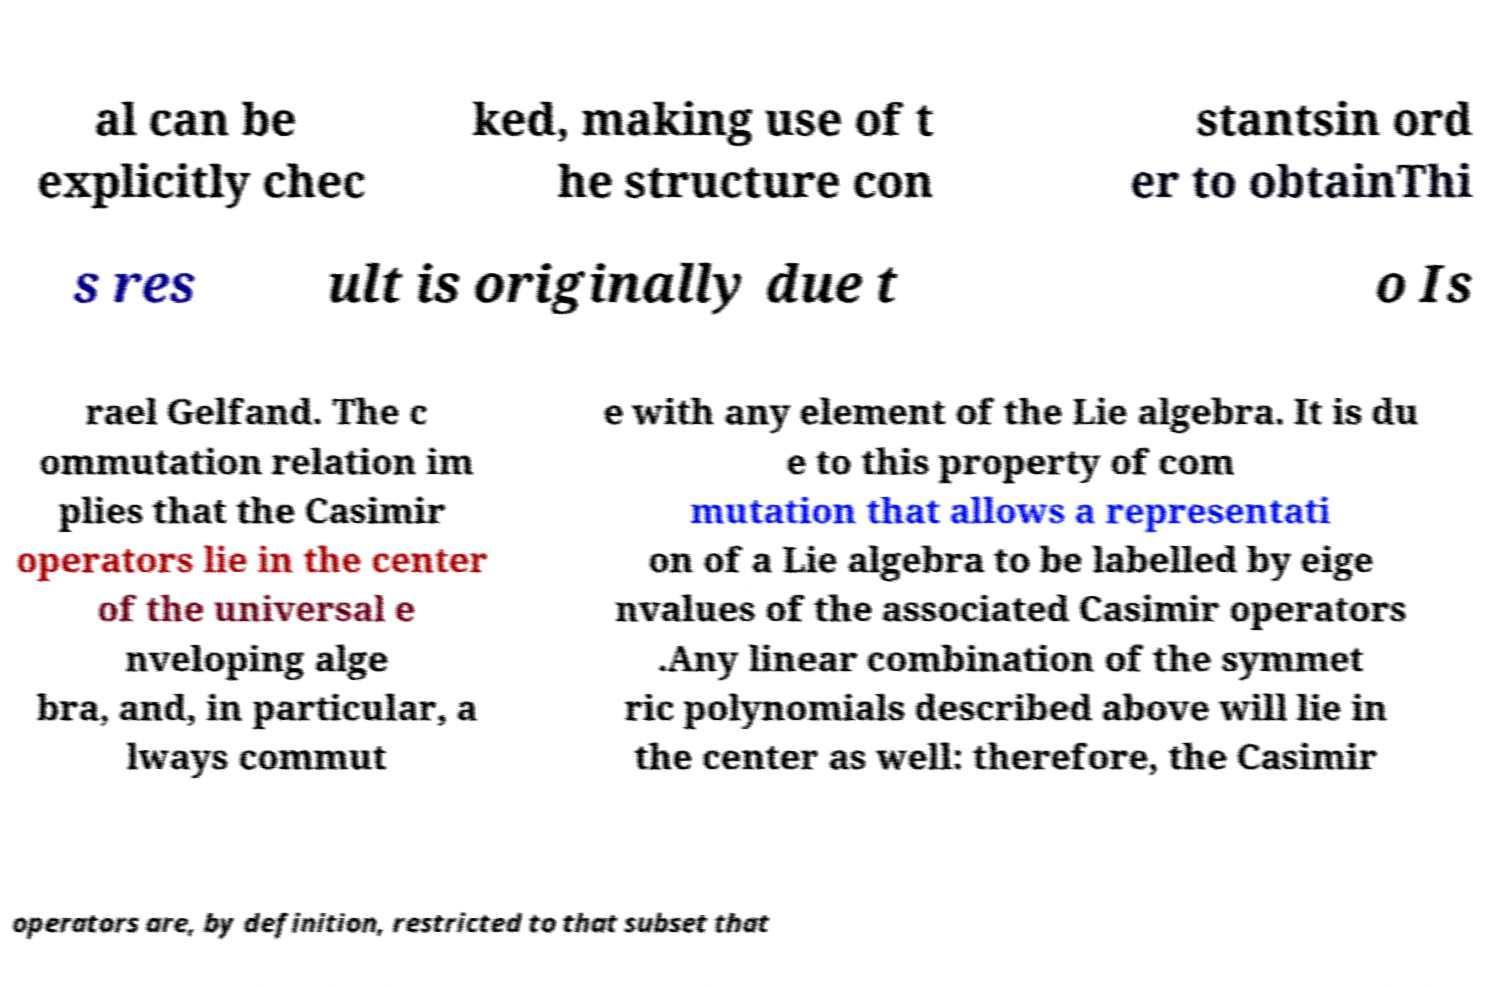Please read and relay the text visible in this image. What does it say? al can be explicitly chec ked, making use of t he structure con stantsin ord er to obtainThi s res ult is originally due t o Is rael Gelfand. The c ommutation relation im plies that the Casimir operators lie in the center of the universal e nveloping alge bra, and, in particular, a lways commut e with any element of the Lie algebra. It is du e to this property of com mutation that allows a representati on of a Lie algebra to be labelled by eige nvalues of the associated Casimir operators .Any linear combination of the symmet ric polynomials described above will lie in the center as well: therefore, the Casimir operators are, by definition, restricted to that subset that 